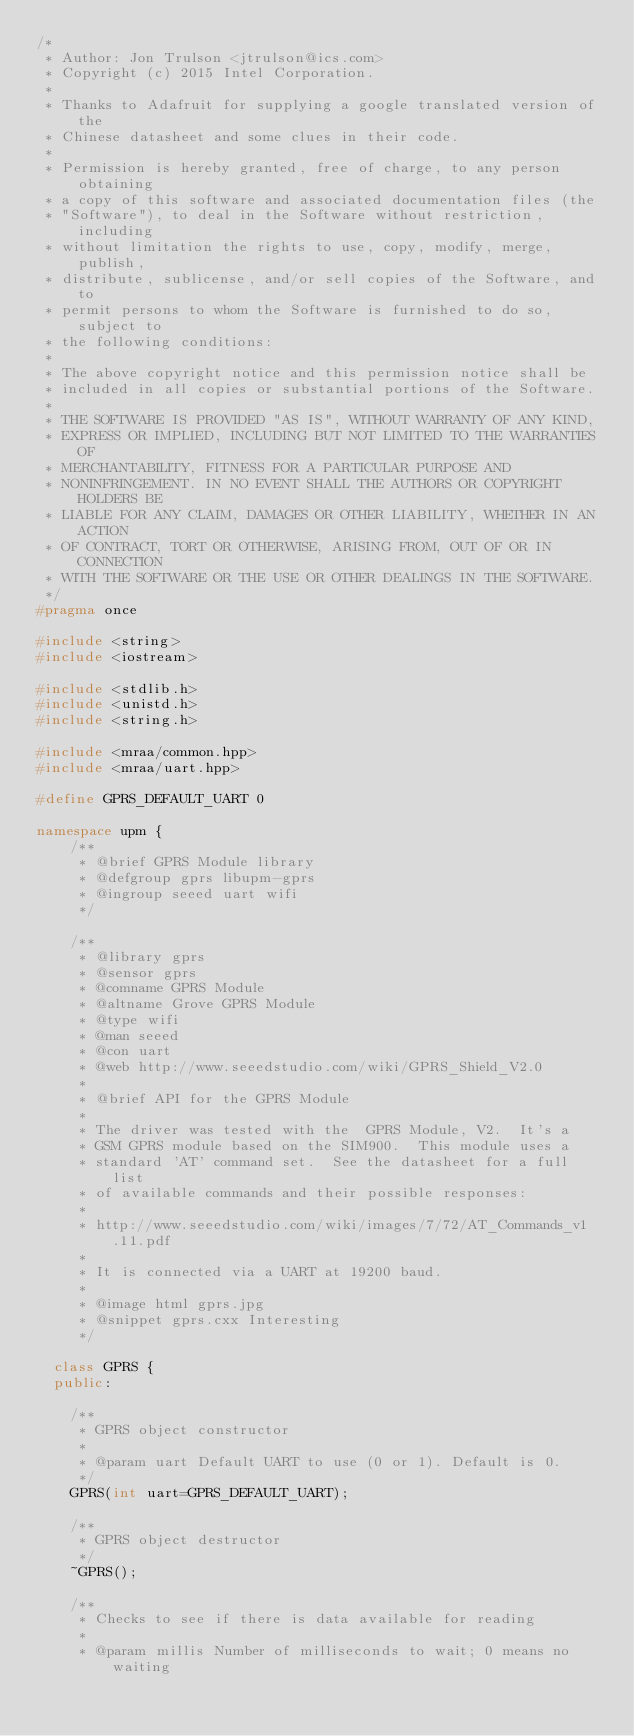<code> <loc_0><loc_0><loc_500><loc_500><_C++_>/*
 * Author: Jon Trulson <jtrulson@ics.com>
 * Copyright (c) 2015 Intel Corporation.
 *
 * Thanks to Adafruit for supplying a google translated version of the
 * Chinese datasheet and some clues in their code.
 *
 * Permission is hereby granted, free of charge, to any person obtaining
 * a copy of this software and associated documentation files (the
 * "Software"), to deal in the Software without restriction, including
 * without limitation the rights to use, copy, modify, merge, publish,
 * distribute, sublicense, and/or sell copies of the Software, and to
 * permit persons to whom the Software is furnished to do so, subject to
 * the following conditions:
 *
 * The above copyright notice and this permission notice shall be
 * included in all copies or substantial portions of the Software.
 *
 * THE SOFTWARE IS PROVIDED "AS IS", WITHOUT WARRANTY OF ANY KIND,
 * EXPRESS OR IMPLIED, INCLUDING BUT NOT LIMITED TO THE WARRANTIES OF
 * MERCHANTABILITY, FITNESS FOR A PARTICULAR PURPOSE AND
 * NONINFRINGEMENT. IN NO EVENT SHALL THE AUTHORS OR COPYRIGHT HOLDERS BE
 * LIABLE FOR ANY CLAIM, DAMAGES OR OTHER LIABILITY, WHETHER IN AN ACTION
 * OF CONTRACT, TORT OR OTHERWISE, ARISING FROM, OUT OF OR IN CONNECTION
 * WITH THE SOFTWARE OR THE USE OR OTHER DEALINGS IN THE SOFTWARE.
 */
#pragma once

#include <string>
#include <iostream>

#include <stdlib.h>
#include <unistd.h>
#include <string.h>

#include <mraa/common.hpp>
#include <mraa/uart.hpp>

#define GPRS_DEFAULT_UART 0

namespace upm {
    /**
     * @brief GPRS Module library
     * @defgroup gprs libupm-gprs
     * @ingroup seeed uart wifi
     */

    /**
     * @library gprs
     * @sensor gprs
     * @comname GPRS Module
     * @altname Grove GPRS Module
     * @type wifi
     * @man seeed
     * @con uart
     * @web http://www.seeedstudio.com/wiki/GPRS_Shield_V2.0
     *
     * @brief API for the GPRS Module
     *
     * The driver was tested with the  GPRS Module, V2.  It's a
     * GSM GPRS module based on the SIM900.  This module uses a
     * standard 'AT' command set.  See the datasheet for a full list
     * of available commands and their possible responses:
     *
     * http://www.seeedstudio.com/wiki/images/7/72/AT_Commands_v1.11.pdf
     *
     * It is connected via a UART at 19200 baud.
     *
     * @image html gprs.jpg
     * @snippet gprs.cxx Interesting
     */

  class GPRS {
  public:

    /**
     * GPRS object constructor
     *
     * @param uart Default UART to use (0 or 1). Default is 0.
     */
    GPRS(int uart=GPRS_DEFAULT_UART);

    /**
     * GPRS object destructor
     */
    ~GPRS();

    /**
     * Checks to see if there is data available for reading
     *
     * @param millis Number of milliseconds to wait; 0 means no waiting</code> 